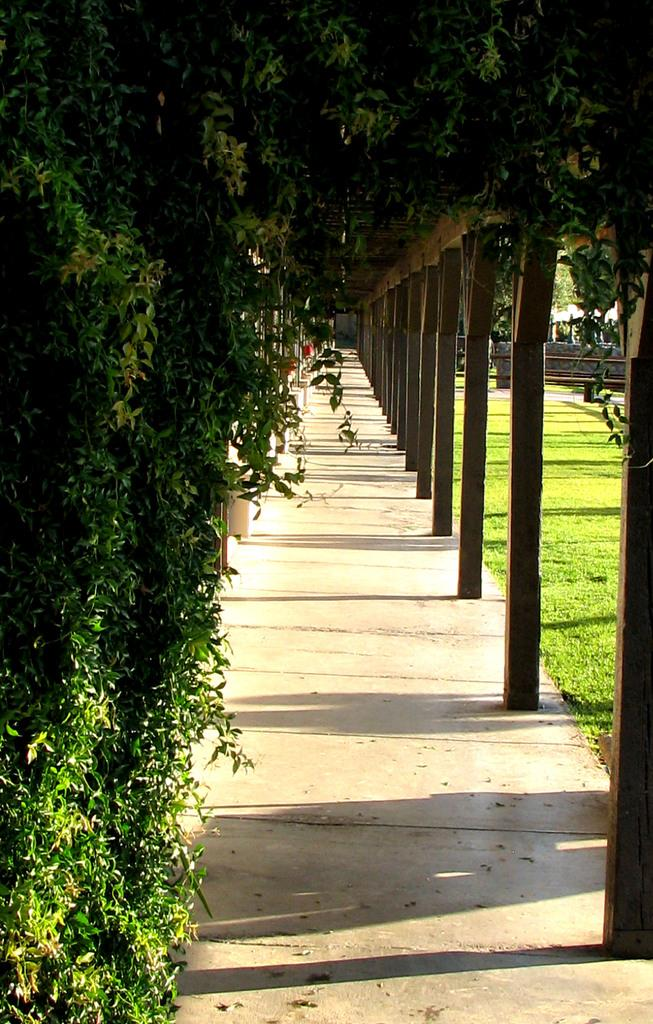What type of surface can be seen beside the pathway in the image? There is a grass surface beside the pathway in the image. What structures are attached to the roof and the wall in the image? There are poles attached to the roof and the wall in the image. What type of vegetation is visible on the wall in the image? There are plants visible on the wall in the image. What is the main feature that runs through the image? The main feature that runs through the image is a pathway. What type of grain can be seen growing on the pathway in the image? There is no grain visible on the pathway in the image. What effect does the swing have on the plants in the image? There is no swing present in the image, so it cannot have any effect on the plants. 